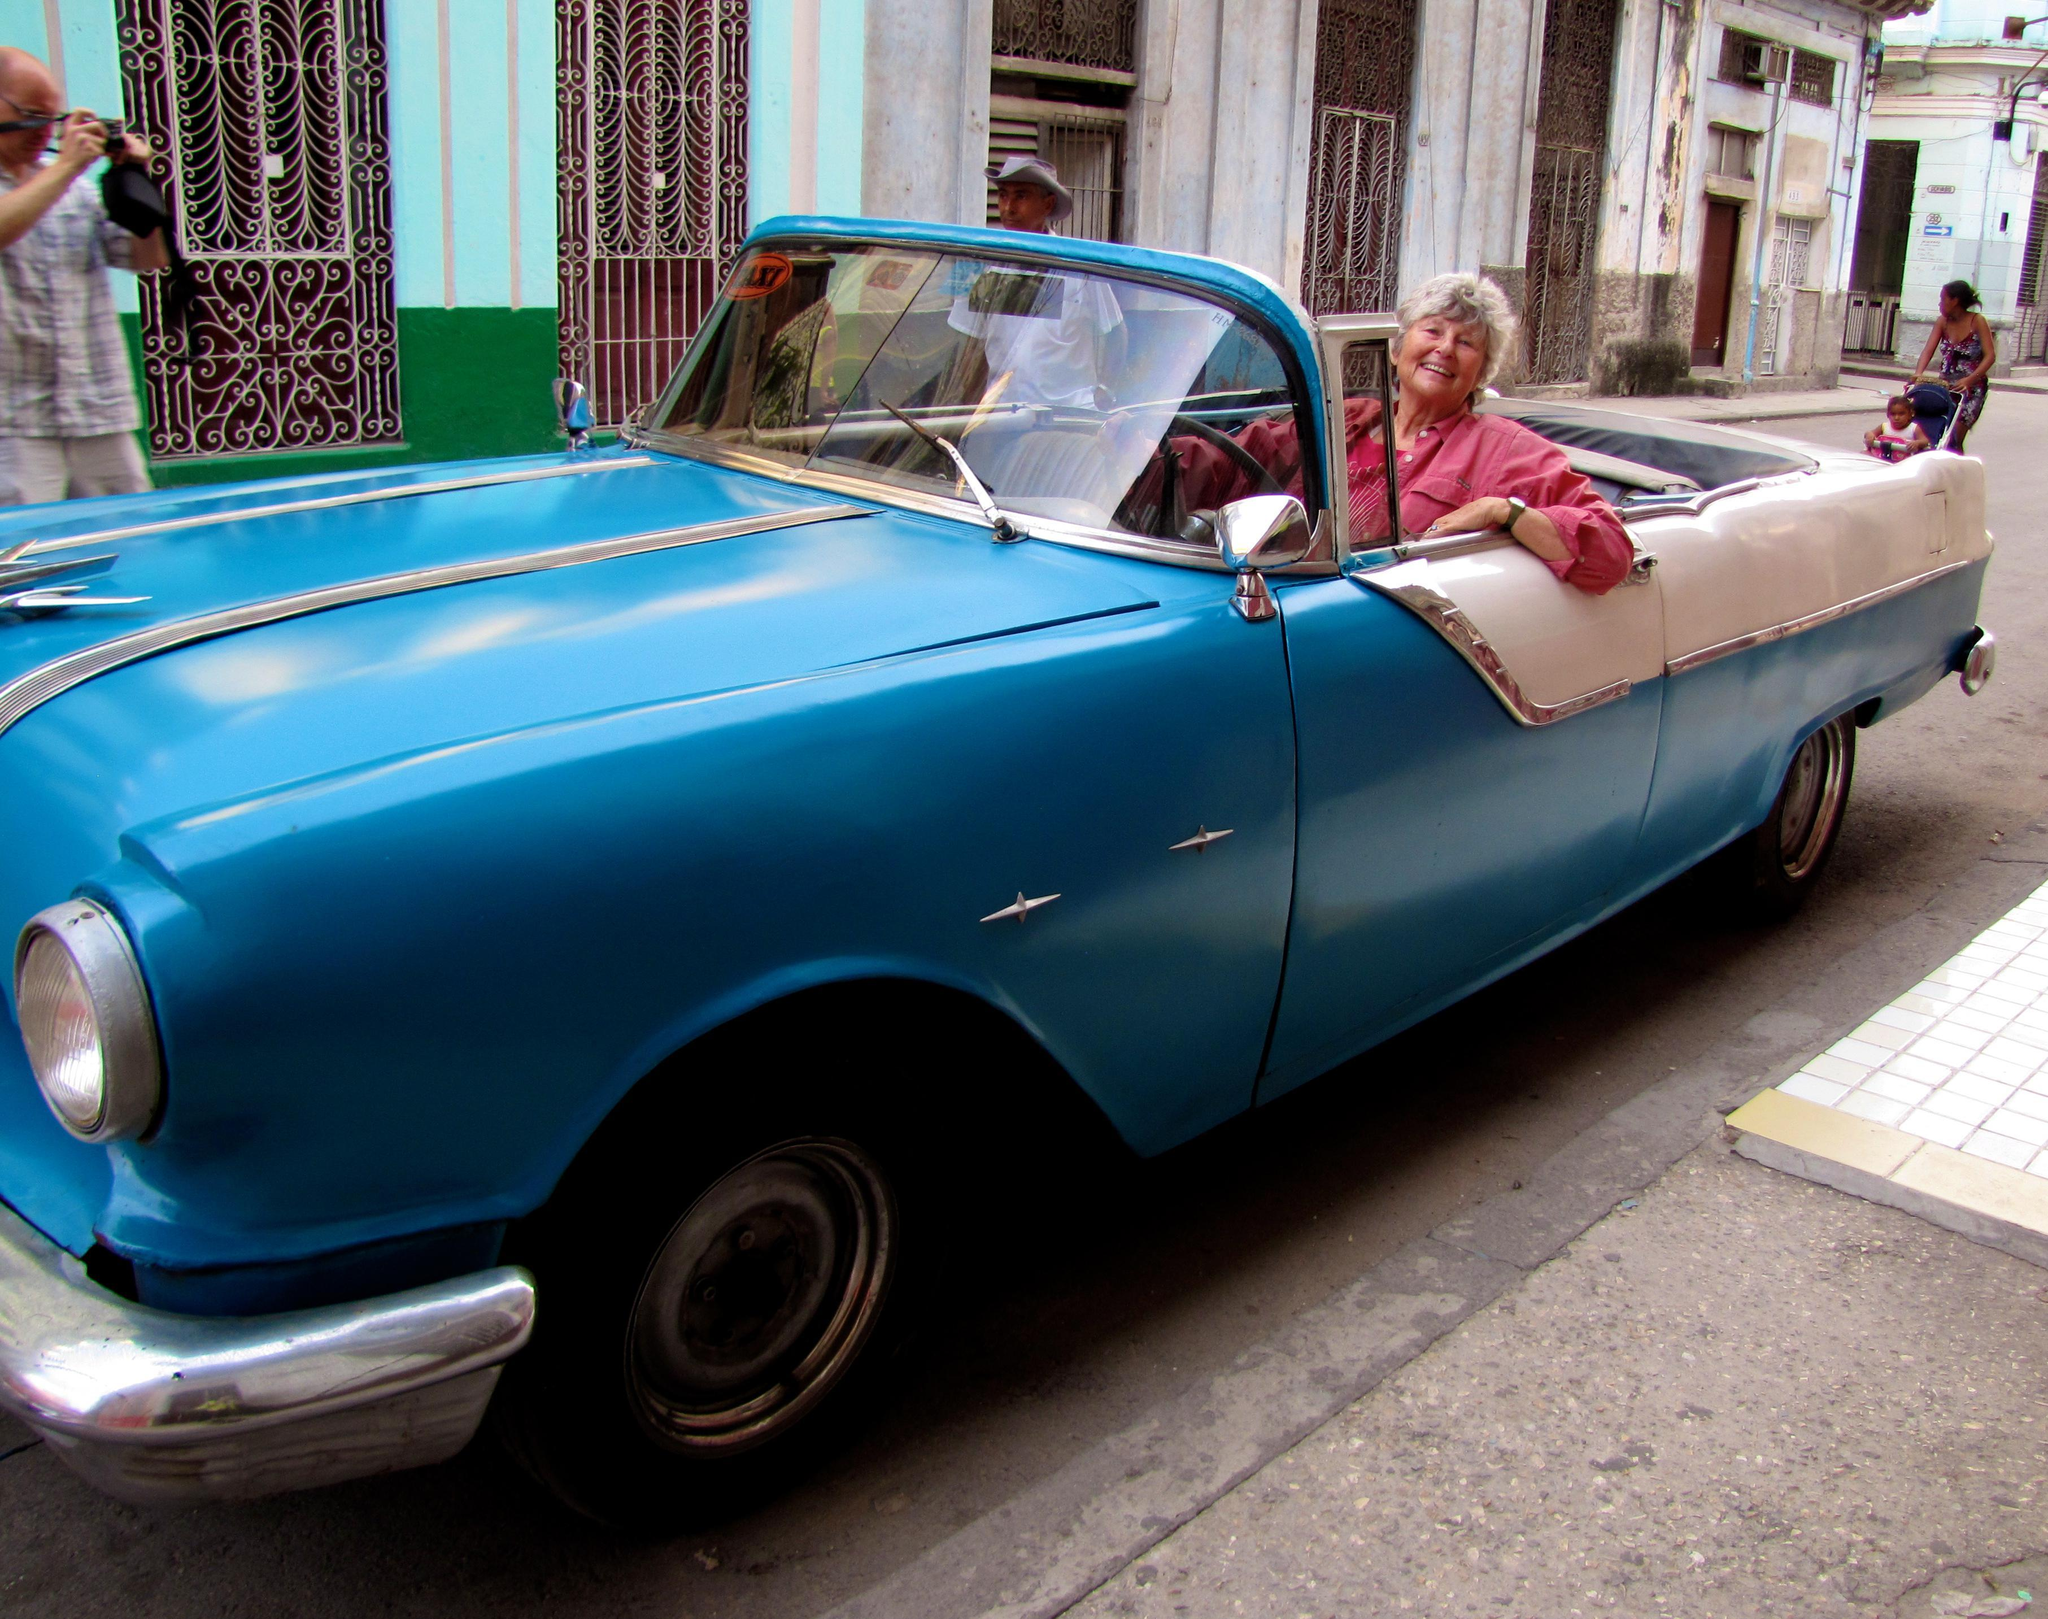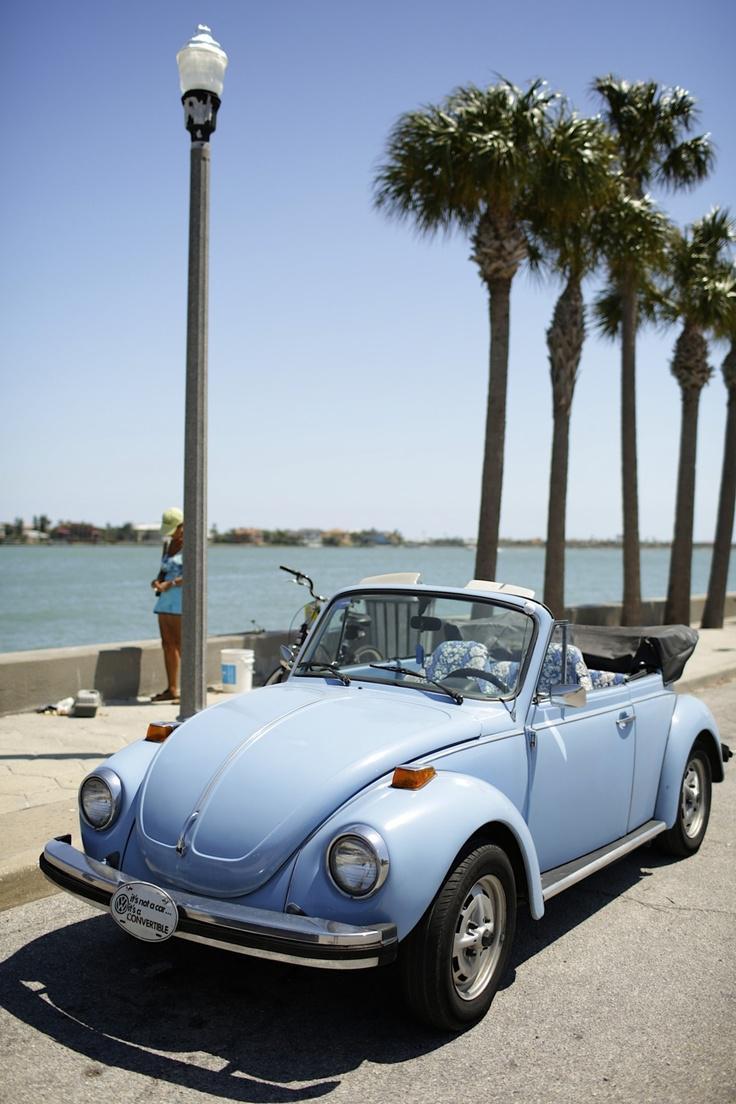The first image is the image on the left, the second image is the image on the right. Evaluate the accuracy of this statement regarding the images: "Both images have a brown wooden fence in the background.". Is it true? Answer yes or no. No. The first image is the image on the left, the second image is the image on the right. For the images shown, is this caption "Two people are sitting in a car in at least one of the images." true? Answer yes or no. No. 